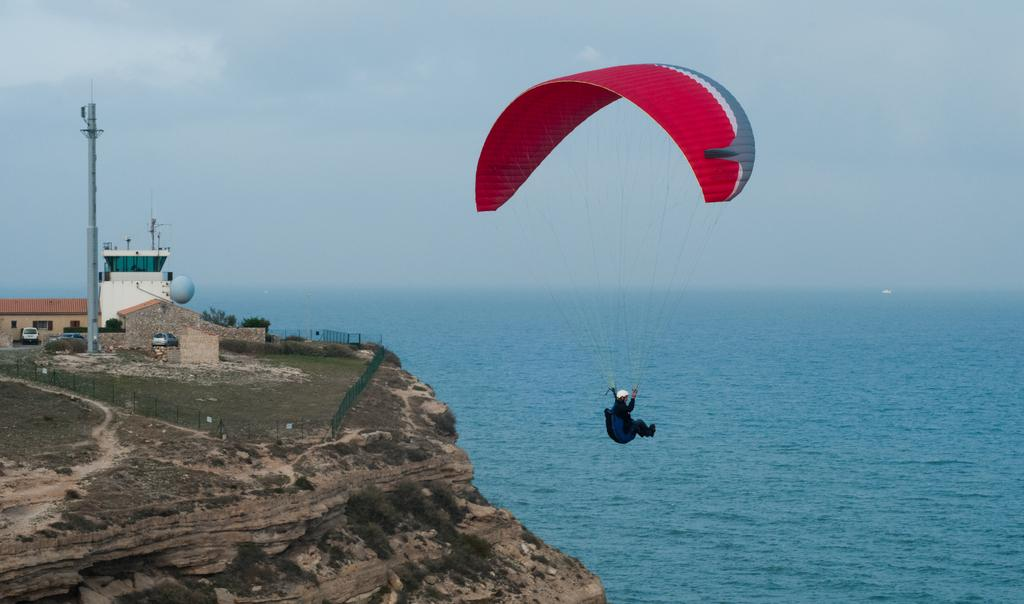What activity is the person in the image engaged in? The person is paragliding in the image. What can be seen on the right side of the image? There is water visible on the right side of the image. What is located on the left side of the image? There is fencing, trees, vehicles, and buildings on the left side of the image. Can you see a monkey eating a yam in the image? No, there is no monkey or yam present in the image. 